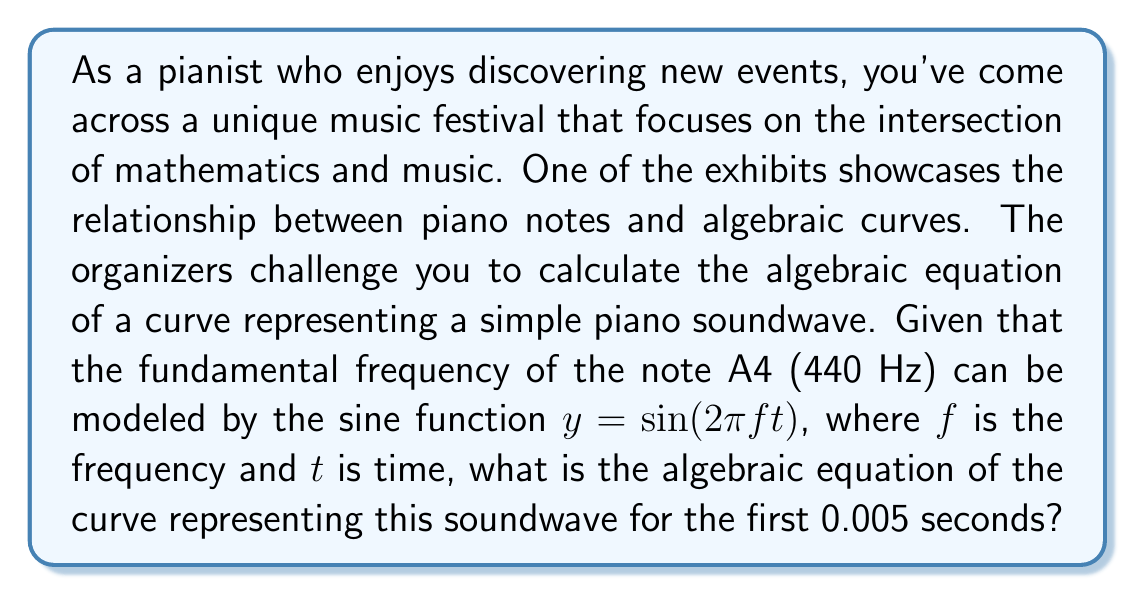Provide a solution to this math problem. Let's approach this step-by-step:

1) We're given that the soundwave can be modeled by the sine function:
   $y = \sin(2\pi ft)$

2) We know that $f = 440$ Hz for the note A4.

3) Substituting this into our equation:
   $y = \sin(2\pi \cdot 440 \cdot t)$

4) Simplify the constant:
   $y = \sin(880\pi t)$

5) To convert this parametric equation into an algebraic equation, we need to eliminate the parameter $t$. We can do this by expressing $t$ in terms of $x$:
   $x = t$ (since $t$ represents time on the x-axis)

6) Substituting this into our equation:
   $y = \sin(880\pi x)$

7) This is already an algebraic equation, but we can make it more standard by moving all terms to one side:
   $y - \sin(880\pi x) = 0$

8) The question asks for the first 0.005 seconds, but this doesn't affect our algebraic equation. It would only limit the domain of $x$ if we were to graph it.
Answer: $y - \sin(880\pi x) = 0$ 